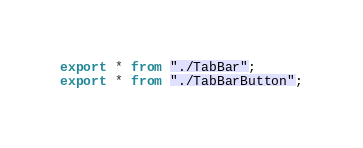<code> <loc_0><loc_0><loc_500><loc_500><_TypeScript_>export * from "./TabBar";
export * from "./TabBarButton";
</code> 